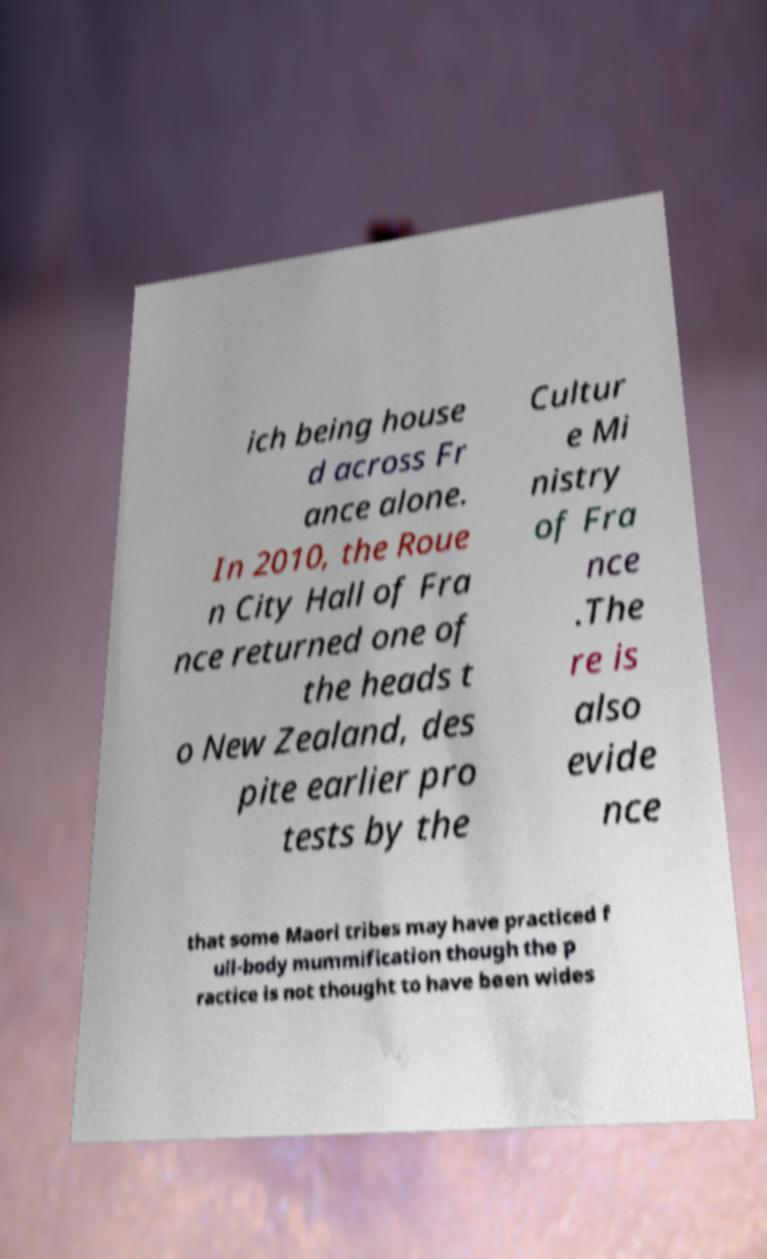Could you assist in decoding the text presented in this image and type it out clearly? ich being house d across Fr ance alone. In 2010, the Roue n City Hall of Fra nce returned one of the heads t o New Zealand, des pite earlier pro tests by the Cultur e Mi nistry of Fra nce .The re is also evide nce that some Maori tribes may have practiced f ull-body mummification though the p ractice is not thought to have been wides 